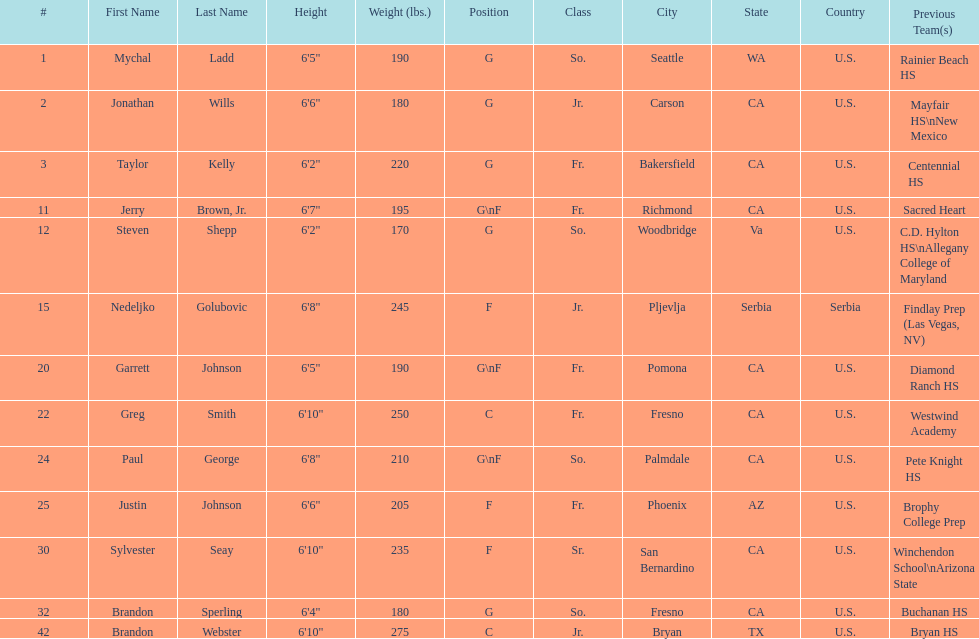How many players and both guard (g) and forward (f)? 3. 